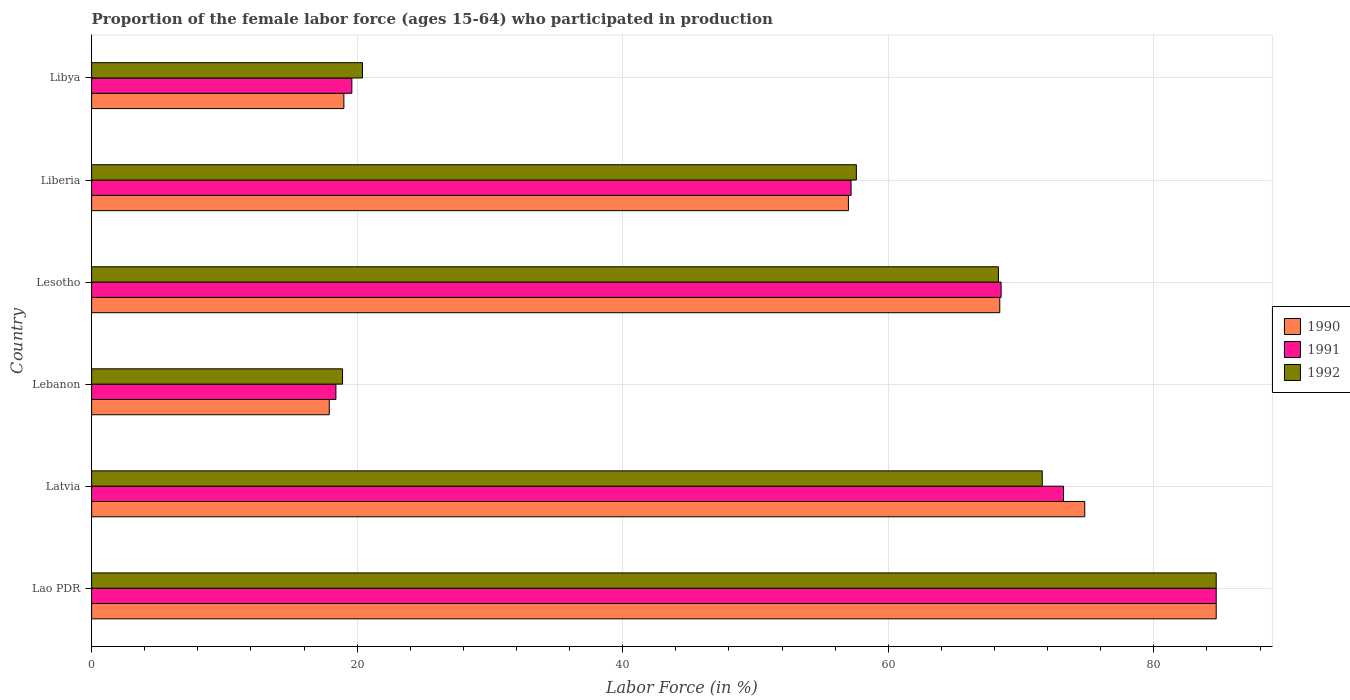How many different coloured bars are there?
Your response must be concise. 3. How many groups of bars are there?
Ensure brevity in your answer.  6. How many bars are there on the 4th tick from the bottom?
Ensure brevity in your answer.  3. What is the label of the 6th group of bars from the top?
Your response must be concise. Lao PDR. What is the proportion of the female labor force who participated in production in 1992 in Libya?
Give a very brief answer. 20.4. Across all countries, what is the maximum proportion of the female labor force who participated in production in 1992?
Provide a succinct answer. 84.7. Across all countries, what is the minimum proportion of the female labor force who participated in production in 1990?
Provide a short and direct response. 17.9. In which country was the proportion of the female labor force who participated in production in 1991 maximum?
Offer a very short reply. Lao PDR. In which country was the proportion of the female labor force who participated in production in 1990 minimum?
Make the answer very short. Lebanon. What is the total proportion of the female labor force who participated in production in 1992 in the graph?
Make the answer very short. 321.5. What is the difference between the proportion of the female labor force who participated in production in 1991 in Lesotho and that in Libya?
Offer a terse response. 48.9. What is the difference between the proportion of the female labor force who participated in production in 1991 in Lebanon and the proportion of the female labor force who participated in production in 1990 in Latvia?
Provide a succinct answer. -56.4. What is the average proportion of the female labor force who participated in production in 1990 per country?
Your answer should be very brief. 53.63. What is the difference between the proportion of the female labor force who participated in production in 1990 and proportion of the female labor force who participated in production in 1992 in Lebanon?
Your answer should be very brief. -1. What is the ratio of the proportion of the female labor force who participated in production in 1990 in Lesotho to that in Libya?
Your response must be concise. 3.6. What is the difference between the highest and the second highest proportion of the female labor force who participated in production in 1990?
Your answer should be very brief. 9.9. What is the difference between the highest and the lowest proportion of the female labor force who participated in production in 1990?
Offer a very short reply. 66.8. What does the 2nd bar from the top in Lesotho represents?
Give a very brief answer. 1991. What does the 1st bar from the bottom in Libya represents?
Provide a succinct answer. 1990. Is it the case that in every country, the sum of the proportion of the female labor force who participated in production in 1990 and proportion of the female labor force who participated in production in 1992 is greater than the proportion of the female labor force who participated in production in 1991?
Offer a terse response. Yes. How many bars are there?
Keep it short and to the point. 18. Are all the bars in the graph horizontal?
Keep it short and to the point. Yes. What is the difference between two consecutive major ticks on the X-axis?
Provide a short and direct response. 20. Are the values on the major ticks of X-axis written in scientific E-notation?
Keep it short and to the point. No. Does the graph contain any zero values?
Provide a short and direct response. No. Does the graph contain grids?
Offer a very short reply. Yes. Where does the legend appear in the graph?
Make the answer very short. Center right. How many legend labels are there?
Offer a very short reply. 3. What is the title of the graph?
Your answer should be compact. Proportion of the female labor force (ages 15-64) who participated in production. What is the label or title of the Y-axis?
Ensure brevity in your answer.  Country. What is the Labor Force (in %) of 1990 in Lao PDR?
Provide a short and direct response. 84.7. What is the Labor Force (in %) of 1991 in Lao PDR?
Your answer should be compact. 84.7. What is the Labor Force (in %) of 1992 in Lao PDR?
Offer a very short reply. 84.7. What is the Labor Force (in %) in 1990 in Latvia?
Make the answer very short. 74.8. What is the Labor Force (in %) of 1991 in Latvia?
Your answer should be compact. 73.2. What is the Labor Force (in %) in 1992 in Latvia?
Offer a terse response. 71.6. What is the Labor Force (in %) of 1990 in Lebanon?
Make the answer very short. 17.9. What is the Labor Force (in %) of 1991 in Lebanon?
Offer a terse response. 18.4. What is the Labor Force (in %) of 1992 in Lebanon?
Offer a terse response. 18.9. What is the Labor Force (in %) in 1990 in Lesotho?
Give a very brief answer. 68.4. What is the Labor Force (in %) of 1991 in Lesotho?
Provide a succinct answer. 68.5. What is the Labor Force (in %) in 1992 in Lesotho?
Your answer should be very brief. 68.3. What is the Labor Force (in %) of 1991 in Liberia?
Keep it short and to the point. 57.2. What is the Labor Force (in %) of 1992 in Liberia?
Ensure brevity in your answer.  57.6. What is the Labor Force (in %) of 1991 in Libya?
Provide a short and direct response. 19.6. What is the Labor Force (in %) in 1992 in Libya?
Ensure brevity in your answer.  20.4. Across all countries, what is the maximum Labor Force (in %) of 1990?
Your answer should be very brief. 84.7. Across all countries, what is the maximum Labor Force (in %) of 1991?
Give a very brief answer. 84.7. Across all countries, what is the maximum Labor Force (in %) of 1992?
Make the answer very short. 84.7. Across all countries, what is the minimum Labor Force (in %) of 1990?
Make the answer very short. 17.9. Across all countries, what is the minimum Labor Force (in %) of 1991?
Offer a terse response. 18.4. Across all countries, what is the minimum Labor Force (in %) in 1992?
Your answer should be compact. 18.9. What is the total Labor Force (in %) of 1990 in the graph?
Your response must be concise. 321.8. What is the total Labor Force (in %) in 1991 in the graph?
Provide a succinct answer. 321.6. What is the total Labor Force (in %) in 1992 in the graph?
Ensure brevity in your answer.  321.5. What is the difference between the Labor Force (in %) of 1990 in Lao PDR and that in Latvia?
Provide a short and direct response. 9.9. What is the difference between the Labor Force (in %) of 1991 in Lao PDR and that in Latvia?
Your answer should be very brief. 11.5. What is the difference between the Labor Force (in %) in 1992 in Lao PDR and that in Latvia?
Provide a short and direct response. 13.1. What is the difference between the Labor Force (in %) in 1990 in Lao PDR and that in Lebanon?
Keep it short and to the point. 66.8. What is the difference between the Labor Force (in %) in 1991 in Lao PDR and that in Lebanon?
Your response must be concise. 66.3. What is the difference between the Labor Force (in %) of 1992 in Lao PDR and that in Lebanon?
Offer a very short reply. 65.8. What is the difference between the Labor Force (in %) of 1990 in Lao PDR and that in Lesotho?
Offer a very short reply. 16.3. What is the difference between the Labor Force (in %) in 1990 in Lao PDR and that in Liberia?
Give a very brief answer. 27.7. What is the difference between the Labor Force (in %) of 1992 in Lao PDR and that in Liberia?
Your response must be concise. 27.1. What is the difference between the Labor Force (in %) in 1990 in Lao PDR and that in Libya?
Keep it short and to the point. 65.7. What is the difference between the Labor Force (in %) in 1991 in Lao PDR and that in Libya?
Your response must be concise. 65.1. What is the difference between the Labor Force (in %) of 1992 in Lao PDR and that in Libya?
Ensure brevity in your answer.  64.3. What is the difference between the Labor Force (in %) of 1990 in Latvia and that in Lebanon?
Make the answer very short. 56.9. What is the difference between the Labor Force (in %) in 1991 in Latvia and that in Lebanon?
Provide a succinct answer. 54.8. What is the difference between the Labor Force (in %) in 1992 in Latvia and that in Lebanon?
Offer a terse response. 52.7. What is the difference between the Labor Force (in %) in 1992 in Latvia and that in Liberia?
Keep it short and to the point. 14. What is the difference between the Labor Force (in %) of 1990 in Latvia and that in Libya?
Your response must be concise. 55.8. What is the difference between the Labor Force (in %) in 1991 in Latvia and that in Libya?
Provide a succinct answer. 53.6. What is the difference between the Labor Force (in %) in 1992 in Latvia and that in Libya?
Ensure brevity in your answer.  51.2. What is the difference between the Labor Force (in %) in 1990 in Lebanon and that in Lesotho?
Keep it short and to the point. -50.5. What is the difference between the Labor Force (in %) of 1991 in Lebanon and that in Lesotho?
Provide a succinct answer. -50.1. What is the difference between the Labor Force (in %) of 1992 in Lebanon and that in Lesotho?
Give a very brief answer. -49.4. What is the difference between the Labor Force (in %) of 1990 in Lebanon and that in Liberia?
Provide a succinct answer. -39.1. What is the difference between the Labor Force (in %) in 1991 in Lebanon and that in Liberia?
Your answer should be very brief. -38.8. What is the difference between the Labor Force (in %) in 1992 in Lebanon and that in Liberia?
Your answer should be compact. -38.7. What is the difference between the Labor Force (in %) of 1991 in Lebanon and that in Libya?
Your answer should be compact. -1.2. What is the difference between the Labor Force (in %) in 1992 in Lebanon and that in Libya?
Offer a very short reply. -1.5. What is the difference between the Labor Force (in %) of 1991 in Lesotho and that in Liberia?
Offer a terse response. 11.3. What is the difference between the Labor Force (in %) in 1990 in Lesotho and that in Libya?
Ensure brevity in your answer.  49.4. What is the difference between the Labor Force (in %) in 1991 in Lesotho and that in Libya?
Offer a very short reply. 48.9. What is the difference between the Labor Force (in %) of 1992 in Lesotho and that in Libya?
Offer a terse response. 47.9. What is the difference between the Labor Force (in %) of 1990 in Liberia and that in Libya?
Offer a very short reply. 38. What is the difference between the Labor Force (in %) in 1991 in Liberia and that in Libya?
Your response must be concise. 37.6. What is the difference between the Labor Force (in %) in 1992 in Liberia and that in Libya?
Make the answer very short. 37.2. What is the difference between the Labor Force (in %) of 1990 in Lao PDR and the Labor Force (in %) of 1992 in Latvia?
Ensure brevity in your answer.  13.1. What is the difference between the Labor Force (in %) in 1991 in Lao PDR and the Labor Force (in %) in 1992 in Latvia?
Your answer should be very brief. 13.1. What is the difference between the Labor Force (in %) in 1990 in Lao PDR and the Labor Force (in %) in 1991 in Lebanon?
Your response must be concise. 66.3. What is the difference between the Labor Force (in %) in 1990 in Lao PDR and the Labor Force (in %) in 1992 in Lebanon?
Provide a short and direct response. 65.8. What is the difference between the Labor Force (in %) in 1991 in Lao PDR and the Labor Force (in %) in 1992 in Lebanon?
Provide a short and direct response. 65.8. What is the difference between the Labor Force (in %) of 1990 in Lao PDR and the Labor Force (in %) of 1991 in Lesotho?
Ensure brevity in your answer.  16.2. What is the difference between the Labor Force (in %) of 1990 in Lao PDR and the Labor Force (in %) of 1991 in Liberia?
Offer a very short reply. 27.5. What is the difference between the Labor Force (in %) of 1990 in Lao PDR and the Labor Force (in %) of 1992 in Liberia?
Keep it short and to the point. 27.1. What is the difference between the Labor Force (in %) in 1991 in Lao PDR and the Labor Force (in %) in 1992 in Liberia?
Offer a very short reply. 27.1. What is the difference between the Labor Force (in %) in 1990 in Lao PDR and the Labor Force (in %) in 1991 in Libya?
Provide a succinct answer. 65.1. What is the difference between the Labor Force (in %) of 1990 in Lao PDR and the Labor Force (in %) of 1992 in Libya?
Make the answer very short. 64.3. What is the difference between the Labor Force (in %) in 1991 in Lao PDR and the Labor Force (in %) in 1992 in Libya?
Offer a terse response. 64.3. What is the difference between the Labor Force (in %) of 1990 in Latvia and the Labor Force (in %) of 1991 in Lebanon?
Your response must be concise. 56.4. What is the difference between the Labor Force (in %) of 1990 in Latvia and the Labor Force (in %) of 1992 in Lebanon?
Offer a very short reply. 55.9. What is the difference between the Labor Force (in %) of 1991 in Latvia and the Labor Force (in %) of 1992 in Lebanon?
Provide a short and direct response. 54.3. What is the difference between the Labor Force (in %) in 1990 in Latvia and the Labor Force (in %) in 1992 in Lesotho?
Provide a short and direct response. 6.5. What is the difference between the Labor Force (in %) of 1991 in Latvia and the Labor Force (in %) of 1992 in Lesotho?
Provide a succinct answer. 4.9. What is the difference between the Labor Force (in %) of 1991 in Latvia and the Labor Force (in %) of 1992 in Liberia?
Offer a very short reply. 15.6. What is the difference between the Labor Force (in %) of 1990 in Latvia and the Labor Force (in %) of 1991 in Libya?
Your answer should be compact. 55.2. What is the difference between the Labor Force (in %) of 1990 in Latvia and the Labor Force (in %) of 1992 in Libya?
Offer a very short reply. 54.4. What is the difference between the Labor Force (in %) of 1991 in Latvia and the Labor Force (in %) of 1992 in Libya?
Give a very brief answer. 52.8. What is the difference between the Labor Force (in %) in 1990 in Lebanon and the Labor Force (in %) in 1991 in Lesotho?
Give a very brief answer. -50.6. What is the difference between the Labor Force (in %) in 1990 in Lebanon and the Labor Force (in %) in 1992 in Lesotho?
Provide a succinct answer. -50.4. What is the difference between the Labor Force (in %) of 1991 in Lebanon and the Labor Force (in %) of 1992 in Lesotho?
Ensure brevity in your answer.  -49.9. What is the difference between the Labor Force (in %) in 1990 in Lebanon and the Labor Force (in %) in 1991 in Liberia?
Your response must be concise. -39.3. What is the difference between the Labor Force (in %) of 1990 in Lebanon and the Labor Force (in %) of 1992 in Liberia?
Provide a succinct answer. -39.7. What is the difference between the Labor Force (in %) of 1991 in Lebanon and the Labor Force (in %) of 1992 in Liberia?
Provide a short and direct response. -39.2. What is the difference between the Labor Force (in %) of 1990 in Lebanon and the Labor Force (in %) of 1991 in Libya?
Give a very brief answer. -1.7. What is the difference between the Labor Force (in %) in 1990 in Lesotho and the Labor Force (in %) in 1991 in Libya?
Your answer should be very brief. 48.8. What is the difference between the Labor Force (in %) in 1990 in Lesotho and the Labor Force (in %) in 1992 in Libya?
Offer a terse response. 48. What is the difference between the Labor Force (in %) of 1991 in Lesotho and the Labor Force (in %) of 1992 in Libya?
Provide a succinct answer. 48.1. What is the difference between the Labor Force (in %) in 1990 in Liberia and the Labor Force (in %) in 1991 in Libya?
Give a very brief answer. 37.4. What is the difference between the Labor Force (in %) in 1990 in Liberia and the Labor Force (in %) in 1992 in Libya?
Ensure brevity in your answer.  36.6. What is the difference between the Labor Force (in %) of 1991 in Liberia and the Labor Force (in %) of 1992 in Libya?
Provide a succinct answer. 36.8. What is the average Labor Force (in %) in 1990 per country?
Offer a terse response. 53.63. What is the average Labor Force (in %) of 1991 per country?
Your answer should be very brief. 53.6. What is the average Labor Force (in %) of 1992 per country?
Your response must be concise. 53.58. What is the difference between the Labor Force (in %) of 1990 and Labor Force (in %) of 1991 in Lao PDR?
Offer a terse response. 0. What is the difference between the Labor Force (in %) of 1990 and Labor Force (in %) of 1992 in Lao PDR?
Offer a terse response. 0. What is the difference between the Labor Force (in %) in 1991 and Labor Force (in %) in 1992 in Lao PDR?
Ensure brevity in your answer.  0. What is the difference between the Labor Force (in %) of 1990 and Labor Force (in %) of 1992 in Lebanon?
Provide a succinct answer. -1. What is the difference between the Labor Force (in %) of 1990 and Labor Force (in %) of 1991 in Liberia?
Offer a very short reply. -0.2. What is the difference between the Labor Force (in %) in 1990 and Labor Force (in %) in 1992 in Liberia?
Keep it short and to the point. -0.6. What is the ratio of the Labor Force (in %) in 1990 in Lao PDR to that in Latvia?
Make the answer very short. 1.13. What is the ratio of the Labor Force (in %) in 1991 in Lao PDR to that in Latvia?
Provide a succinct answer. 1.16. What is the ratio of the Labor Force (in %) of 1992 in Lao PDR to that in Latvia?
Offer a terse response. 1.18. What is the ratio of the Labor Force (in %) in 1990 in Lao PDR to that in Lebanon?
Offer a very short reply. 4.73. What is the ratio of the Labor Force (in %) of 1991 in Lao PDR to that in Lebanon?
Your response must be concise. 4.6. What is the ratio of the Labor Force (in %) of 1992 in Lao PDR to that in Lebanon?
Ensure brevity in your answer.  4.48. What is the ratio of the Labor Force (in %) in 1990 in Lao PDR to that in Lesotho?
Offer a terse response. 1.24. What is the ratio of the Labor Force (in %) in 1991 in Lao PDR to that in Lesotho?
Ensure brevity in your answer.  1.24. What is the ratio of the Labor Force (in %) of 1992 in Lao PDR to that in Lesotho?
Provide a succinct answer. 1.24. What is the ratio of the Labor Force (in %) in 1990 in Lao PDR to that in Liberia?
Provide a succinct answer. 1.49. What is the ratio of the Labor Force (in %) of 1991 in Lao PDR to that in Liberia?
Your response must be concise. 1.48. What is the ratio of the Labor Force (in %) in 1992 in Lao PDR to that in Liberia?
Offer a terse response. 1.47. What is the ratio of the Labor Force (in %) in 1990 in Lao PDR to that in Libya?
Your response must be concise. 4.46. What is the ratio of the Labor Force (in %) in 1991 in Lao PDR to that in Libya?
Give a very brief answer. 4.32. What is the ratio of the Labor Force (in %) of 1992 in Lao PDR to that in Libya?
Make the answer very short. 4.15. What is the ratio of the Labor Force (in %) of 1990 in Latvia to that in Lebanon?
Offer a very short reply. 4.18. What is the ratio of the Labor Force (in %) in 1991 in Latvia to that in Lebanon?
Provide a succinct answer. 3.98. What is the ratio of the Labor Force (in %) in 1992 in Latvia to that in Lebanon?
Your answer should be compact. 3.79. What is the ratio of the Labor Force (in %) in 1990 in Latvia to that in Lesotho?
Your answer should be compact. 1.09. What is the ratio of the Labor Force (in %) of 1991 in Latvia to that in Lesotho?
Keep it short and to the point. 1.07. What is the ratio of the Labor Force (in %) of 1992 in Latvia to that in Lesotho?
Your answer should be very brief. 1.05. What is the ratio of the Labor Force (in %) in 1990 in Latvia to that in Liberia?
Keep it short and to the point. 1.31. What is the ratio of the Labor Force (in %) in 1991 in Latvia to that in Liberia?
Your response must be concise. 1.28. What is the ratio of the Labor Force (in %) in 1992 in Latvia to that in Liberia?
Your answer should be very brief. 1.24. What is the ratio of the Labor Force (in %) in 1990 in Latvia to that in Libya?
Make the answer very short. 3.94. What is the ratio of the Labor Force (in %) of 1991 in Latvia to that in Libya?
Offer a very short reply. 3.73. What is the ratio of the Labor Force (in %) of 1992 in Latvia to that in Libya?
Ensure brevity in your answer.  3.51. What is the ratio of the Labor Force (in %) of 1990 in Lebanon to that in Lesotho?
Offer a very short reply. 0.26. What is the ratio of the Labor Force (in %) in 1991 in Lebanon to that in Lesotho?
Offer a terse response. 0.27. What is the ratio of the Labor Force (in %) of 1992 in Lebanon to that in Lesotho?
Give a very brief answer. 0.28. What is the ratio of the Labor Force (in %) in 1990 in Lebanon to that in Liberia?
Provide a short and direct response. 0.31. What is the ratio of the Labor Force (in %) of 1991 in Lebanon to that in Liberia?
Ensure brevity in your answer.  0.32. What is the ratio of the Labor Force (in %) of 1992 in Lebanon to that in Liberia?
Your answer should be compact. 0.33. What is the ratio of the Labor Force (in %) of 1990 in Lebanon to that in Libya?
Provide a succinct answer. 0.94. What is the ratio of the Labor Force (in %) of 1991 in Lebanon to that in Libya?
Ensure brevity in your answer.  0.94. What is the ratio of the Labor Force (in %) of 1992 in Lebanon to that in Libya?
Your answer should be very brief. 0.93. What is the ratio of the Labor Force (in %) in 1990 in Lesotho to that in Liberia?
Provide a short and direct response. 1.2. What is the ratio of the Labor Force (in %) in 1991 in Lesotho to that in Liberia?
Provide a succinct answer. 1.2. What is the ratio of the Labor Force (in %) in 1992 in Lesotho to that in Liberia?
Give a very brief answer. 1.19. What is the ratio of the Labor Force (in %) of 1991 in Lesotho to that in Libya?
Give a very brief answer. 3.49. What is the ratio of the Labor Force (in %) in 1992 in Lesotho to that in Libya?
Offer a terse response. 3.35. What is the ratio of the Labor Force (in %) in 1990 in Liberia to that in Libya?
Give a very brief answer. 3. What is the ratio of the Labor Force (in %) of 1991 in Liberia to that in Libya?
Ensure brevity in your answer.  2.92. What is the ratio of the Labor Force (in %) in 1992 in Liberia to that in Libya?
Give a very brief answer. 2.82. What is the difference between the highest and the second highest Labor Force (in %) of 1992?
Provide a short and direct response. 13.1. What is the difference between the highest and the lowest Labor Force (in %) in 1990?
Your answer should be compact. 66.8. What is the difference between the highest and the lowest Labor Force (in %) in 1991?
Make the answer very short. 66.3. What is the difference between the highest and the lowest Labor Force (in %) of 1992?
Give a very brief answer. 65.8. 